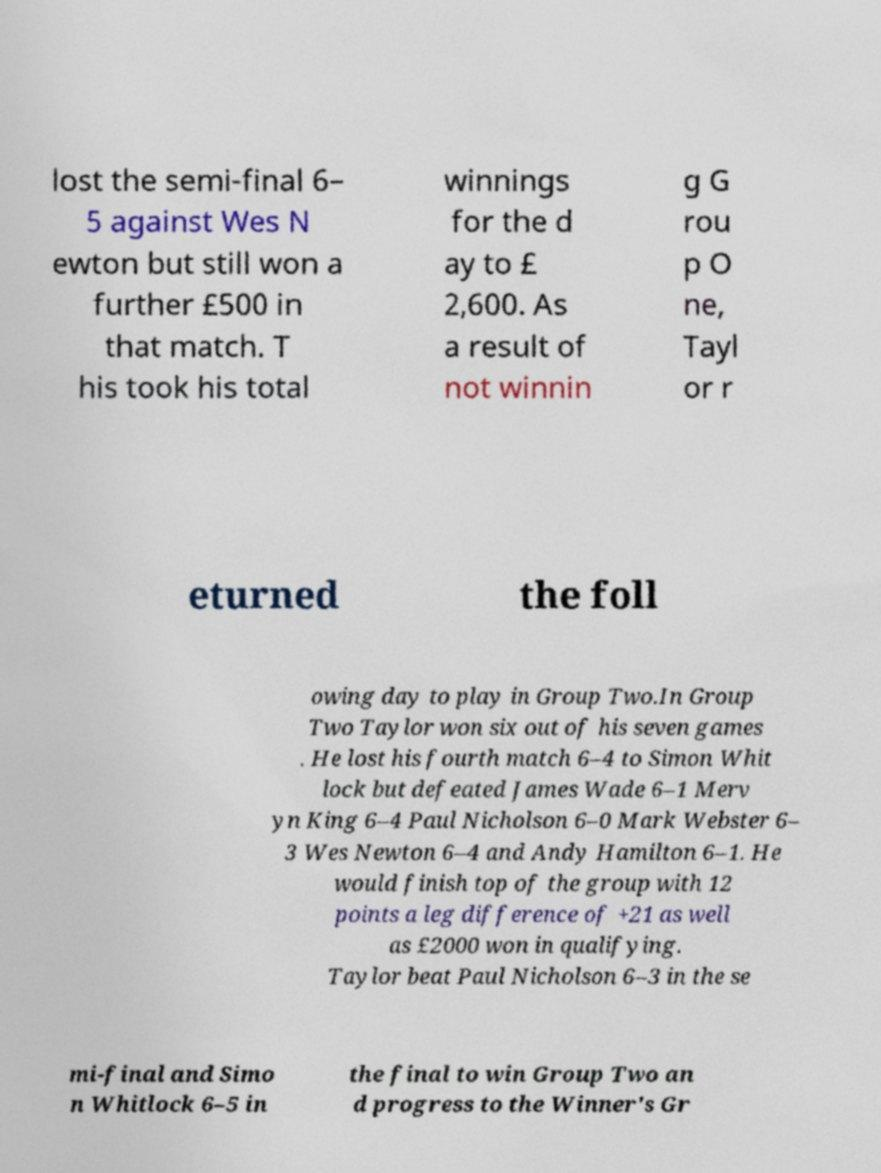Can you read and provide the text displayed in the image?This photo seems to have some interesting text. Can you extract and type it out for me? lost the semi-final 6– 5 against Wes N ewton but still won a further £500 in that match. T his took his total winnings for the d ay to £ 2,600. As a result of not winnin g G rou p O ne, Tayl or r eturned the foll owing day to play in Group Two.In Group Two Taylor won six out of his seven games . He lost his fourth match 6–4 to Simon Whit lock but defeated James Wade 6–1 Merv yn King 6–4 Paul Nicholson 6–0 Mark Webster 6– 3 Wes Newton 6–4 and Andy Hamilton 6–1. He would finish top of the group with 12 points a leg difference of +21 as well as £2000 won in qualifying. Taylor beat Paul Nicholson 6–3 in the se mi-final and Simo n Whitlock 6–5 in the final to win Group Two an d progress to the Winner's Gr 